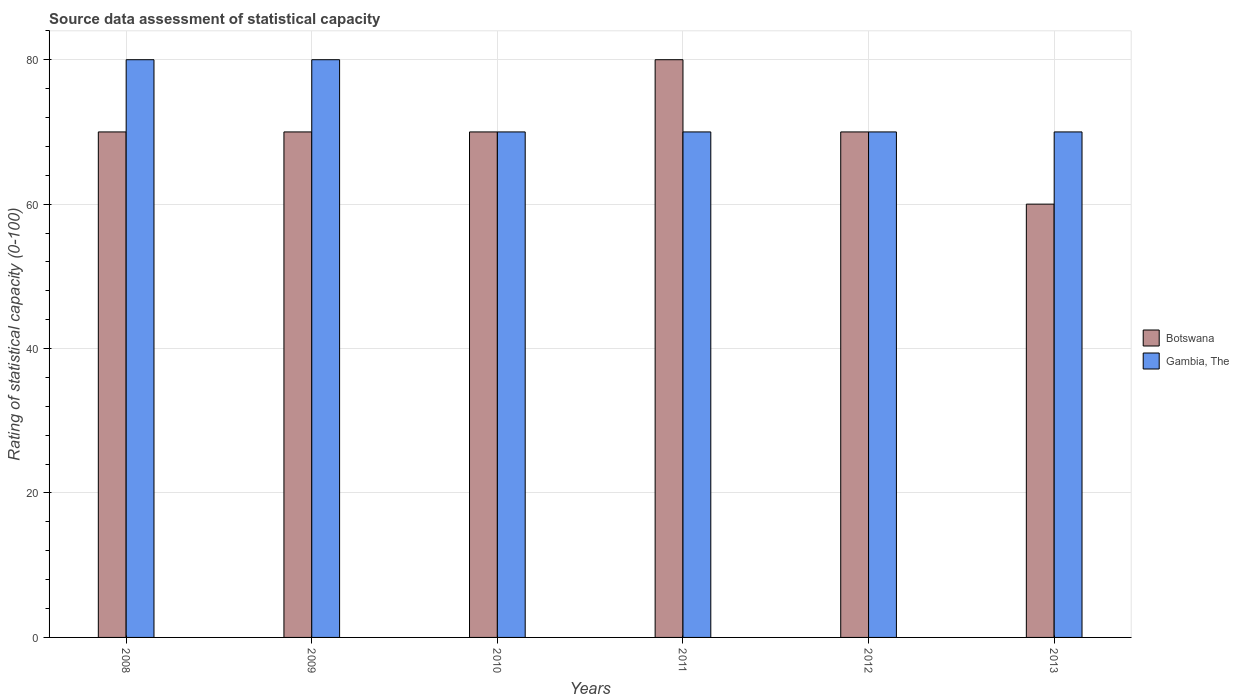Are the number of bars on each tick of the X-axis equal?
Your response must be concise. Yes. How many bars are there on the 3rd tick from the left?
Provide a short and direct response. 2. How many bars are there on the 1st tick from the right?
Ensure brevity in your answer.  2. What is the rating of statistical capacity in Gambia, The in 2010?
Give a very brief answer. 70. Across all years, what is the maximum rating of statistical capacity in Botswana?
Give a very brief answer. 80. Across all years, what is the minimum rating of statistical capacity in Botswana?
Offer a very short reply. 60. In which year was the rating of statistical capacity in Botswana maximum?
Ensure brevity in your answer.  2011. In which year was the rating of statistical capacity in Gambia, The minimum?
Make the answer very short. 2010. What is the total rating of statistical capacity in Gambia, The in the graph?
Provide a short and direct response. 440. What is the difference between the rating of statistical capacity in Botswana in 2008 and that in 2013?
Your response must be concise. 10. What is the average rating of statistical capacity in Botswana per year?
Your response must be concise. 70. In the year 2008, what is the difference between the rating of statistical capacity in Botswana and rating of statistical capacity in Gambia, The?
Provide a succinct answer. -10. What is the ratio of the rating of statistical capacity in Gambia, The in 2009 to that in 2012?
Give a very brief answer. 1.14. What is the difference between the highest and the second highest rating of statistical capacity in Botswana?
Give a very brief answer. 10. What is the difference between the highest and the lowest rating of statistical capacity in Gambia, The?
Provide a short and direct response. 10. In how many years, is the rating of statistical capacity in Gambia, The greater than the average rating of statistical capacity in Gambia, The taken over all years?
Give a very brief answer. 2. What does the 1st bar from the left in 2009 represents?
Provide a succinct answer. Botswana. What does the 2nd bar from the right in 2011 represents?
Make the answer very short. Botswana. How many bars are there?
Your answer should be very brief. 12. Are all the bars in the graph horizontal?
Provide a short and direct response. No. What is the difference between two consecutive major ticks on the Y-axis?
Provide a succinct answer. 20. Does the graph contain any zero values?
Provide a short and direct response. No. Does the graph contain grids?
Keep it short and to the point. Yes. Where does the legend appear in the graph?
Give a very brief answer. Center right. How are the legend labels stacked?
Give a very brief answer. Vertical. What is the title of the graph?
Provide a succinct answer. Source data assessment of statistical capacity. Does "French Polynesia" appear as one of the legend labels in the graph?
Offer a very short reply. No. What is the label or title of the Y-axis?
Your answer should be very brief. Rating of statistical capacity (0-100). What is the Rating of statistical capacity (0-100) in Botswana in 2008?
Ensure brevity in your answer.  70. What is the Rating of statistical capacity (0-100) in Gambia, The in 2009?
Provide a short and direct response. 80. What is the Rating of statistical capacity (0-100) in Gambia, The in 2010?
Offer a terse response. 70. What is the Rating of statistical capacity (0-100) of Botswana in 2011?
Offer a terse response. 80. What is the Rating of statistical capacity (0-100) of Gambia, The in 2011?
Provide a short and direct response. 70. What is the Rating of statistical capacity (0-100) in Gambia, The in 2012?
Offer a terse response. 70. Across all years, what is the maximum Rating of statistical capacity (0-100) of Botswana?
Your answer should be very brief. 80. Across all years, what is the maximum Rating of statistical capacity (0-100) in Gambia, The?
Give a very brief answer. 80. Across all years, what is the minimum Rating of statistical capacity (0-100) of Gambia, The?
Your answer should be compact. 70. What is the total Rating of statistical capacity (0-100) of Botswana in the graph?
Keep it short and to the point. 420. What is the total Rating of statistical capacity (0-100) of Gambia, The in the graph?
Provide a succinct answer. 440. What is the difference between the Rating of statistical capacity (0-100) in Botswana in 2008 and that in 2010?
Offer a very short reply. 0. What is the difference between the Rating of statistical capacity (0-100) in Gambia, The in 2008 and that in 2010?
Give a very brief answer. 10. What is the difference between the Rating of statistical capacity (0-100) of Gambia, The in 2008 and that in 2011?
Ensure brevity in your answer.  10. What is the difference between the Rating of statistical capacity (0-100) in Botswana in 2008 and that in 2012?
Provide a succinct answer. 0. What is the difference between the Rating of statistical capacity (0-100) in Botswana in 2009 and that in 2010?
Provide a succinct answer. 0. What is the difference between the Rating of statistical capacity (0-100) of Gambia, The in 2009 and that in 2013?
Make the answer very short. 10. What is the difference between the Rating of statistical capacity (0-100) of Botswana in 2010 and that in 2011?
Give a very brief answer. -10. What is the difference between the Rating of statistical capacity (0-100) of Gambia, The in 2010 and that in 2012?
Offer a terse response. 0. What is the difference between the Rating of statistical capacity (0-100) of Botswana in 2010 and that in 2013?
Your answer should be compact. 10. What is the difference between the Rating of statistical capacity (0-100) of Gambia, The in 2010 and that in 2013?
Your answer should be compact. 0. What is the difference between the Rating of statistical capacity (0-100) in Botswana in 2011 and that in 2013?
Ensure brevity in your answer.  20. What is the difference between the Rating of statistical capacity (0-100) of Botswana in 2012 and that in 2013?
Provide a short and direct response. 10. What is the difference between the Rating of statistical capacity (0-100) in Gambia, The in 2012 and that in 2013?
Your answer should be compact. 0. What is the difference between the Rating of statistical capacity (0-100) in Botswana in 2010 and the Rating of statistical capacity (0-100) in Gambia, The in 2012?
Your answer should be very brief. 0. What is the difference between the Rating of statistical capacity (0-100) of Botswana in 2011 and the Rating of statistical capacity (0-100) of Gambia, The in 2012?
Offer a terse response. 10. What is the average Rating of statistical capacity (0-100) of Botswana per year?
Your answer should be very brief. 70. What is the average Rating of statistical capacity (0-100) in Gambia, The per year?
Ensure brevity in your answer.  73.33. In the year 2008, what is the difference between the Rating of statistical capacity (0-100) in Botswana and Rating of statistical capacity (0-100) in Gambia, The?
Provide a succinct answer. -10. In the year 2009, what is the difference between the Rating of statistical capacity (0-100) in Botswana and Rating of statistical capacity (0-100) in Gambia, The?
Ensure brevity in your answer.  -10. In the year 2010, what is the difference between the Rating of statistical capacity (0-100) of Botswana and Rating of statistical capacity (0-100) of Gambia, The?
Ensure brevity in your answer.  0. In the year 2011, what is the difference between the Rating of statistical capacity (0-100) in Botswana and Rating of statistical capacity (0-100) in Gambia, The?
Ensure brevity in your answer.  10. In the year 2012, what is the difference between the Rating of statistical capacity (0-100) in Botswana and Rating of statistical capacity (0-100) in Gambia, The?
Your answer should be compact. 0. In the year 2013, what is the difference between the Rating of statistical capacity (0-100) of Botswana and Rating of statistical capacity (0-100) of Gambia, The?
Make the answer very short. -10. What is the ratio of the Rating of statistical capacity (0-100) of Gambia, The in 2008 to that in 2009?
Keep it short and to the point. 1. What is the ratio of the Rating of statistical capacity (0-100) of Botswana in 2008 to that in 2010?
Keep it short and to the point. 1. What is the ratio of the Rating of statistical capacity (0-100) of Botswana in 2008 to that in 2012?
Offer a very short reply. 1. What is the ratio of the Rating of statistical capacity (0-100) in Botswana in 2008 to that in 2013?
Your answer should be very brief. 1.17. What is the ratio of the Rating of statistical capacity (0-100) in Gambia, The in 2008 to that in 2013?
Your response must be concise. 1.14. What is the ratio of the Rating of statistical capacity (0-100) of Gambia, The in 2009 to that in 2010?
Provide a succinct answer. 1.14. What is the ratio of the Rating of statistical capacity (0-100) of Gambia, The in 2009 to that in 2012?
Give a very brief answer. 1.14. What is the ratio of the Rating of statistical capacity (0-100) of Botswana in 2009 to that in 2013?
Provide a short and direct response. 1.17. What is the ratio of the Rating of statistical capacity (0-100) in Gambia, The in 2010 to that in 2011?
Offer a terse response. 1. What is the ratio of the Rating of statistical capacity (0-100) of Botswana in 2010 to that in 2013?
Provide a short and direct response. 1.17. What is the ratio of the Rating of statistical capacity (0-100) in Botswana in 2011 to that in 2012?
Your response must be concise. 1.14. What is the ratio of the Rating of statistical capacity (0-100) of Gambia, The in 2011 to that in 2012?
Keep it short and to the point. 1. What is the ratio of the Rating of statistical capacity (0-100) of Gambia, The in 2011 to that in 2013?
Offer a terse response. 1. What is the ratio of the Rating of statistical capacity (0-100) in Gambia, The in 2012 to that in 2013?
Keep it short and to the point. 1. What is the difference between the highest and the second highest Rating of statistical capacity (0-100) in Botswana?
Offer a very short reply. 10. What is the difference between the highest and the lowest Rating of statistical capacity (0-100) in Botswana?
Keep it short and to the point. 20. What is the difference between the highest and the lowest Rating of statistical capacity (0-100) in Gambia, The?
Offer a terse response. 10. 